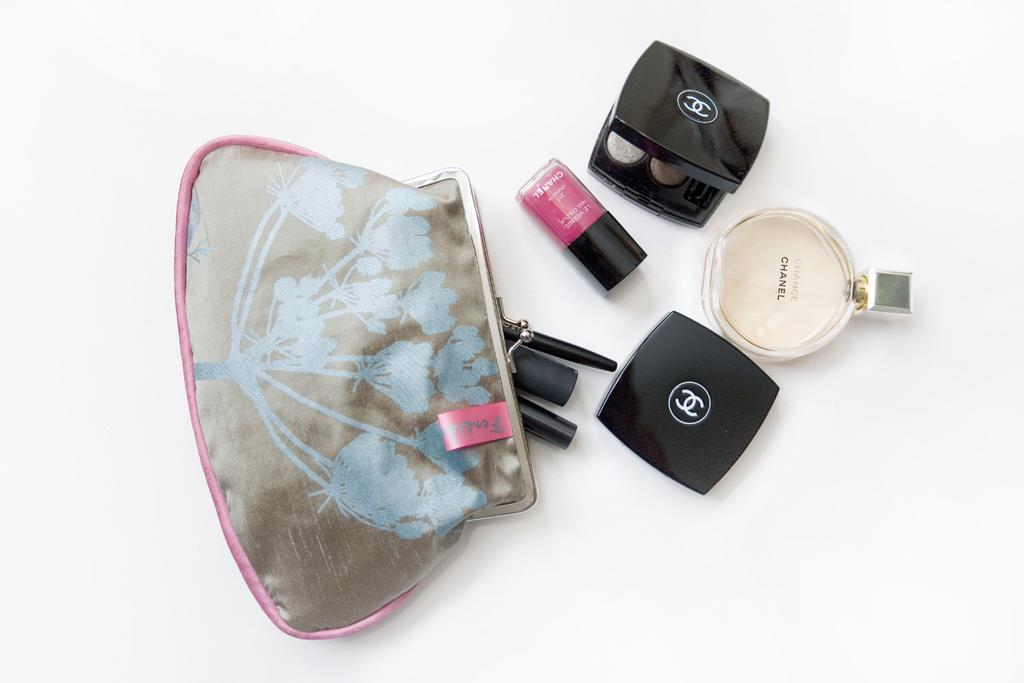What is the main object in the image? There is a perfume bottle in the image. What other items can be seen in the image? There are black color boxes, nail polish, and a pouch with some items in the image. What is the color of the surface on which the objects are placed? The objects are placed on a white surface. How does the perfume bottle affect the bit and throat in the image? The perfume bottle does not affect the bit or throat in the image, as these concepts are not present or relevant to the image. 